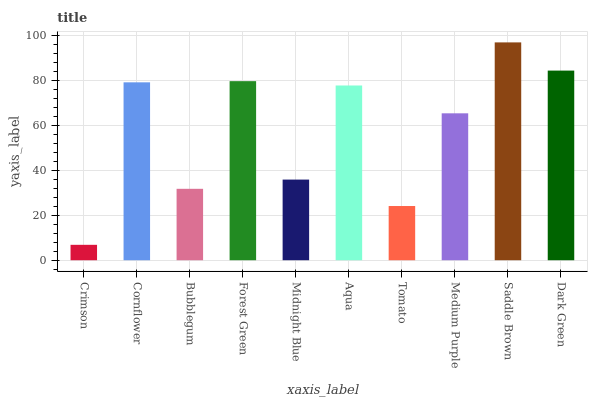Is Cornflower the minimum?
Answer yes or no. No. Is Cornflower the maximum?
Answer yes or no. No. Is Cornflower greater than Crimson?
Answer yes or no. Yes. Is Crimson less than Cornflower?
Answer yes or no. Yes. Is Crimson greater than Cornflower?
Answer yes or no. No. Is Cornflower less than Crimson?
Answer yes or no. No. Is Aqua the high median?
Answer yes or no. Yes. Is Medium Purple the low median?
Answer yes or no. Yes. Is Bubblegum the high median?
Answer yes or no. No. Is Forest Green the low median?
Answer yes or no. No. 